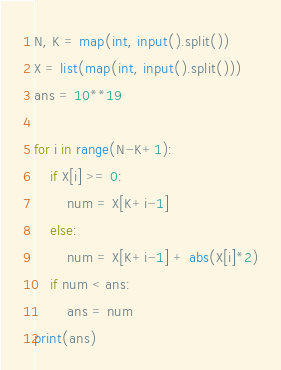Convert code to text. <code><loc_0><loc_0><loc_500><loc_500><_Python_>N, K = map(int, input().split())
X = list(map(int, input().split()))
ans = 10**19

for i in range(N-K+1):
    if X[i] >= 0:
        num = X[K+i-1]
    else:
        num = X[K+i-1] + abs(X[i]*2)
    if num < ans:
        ans = num
print(ans)
</code> 